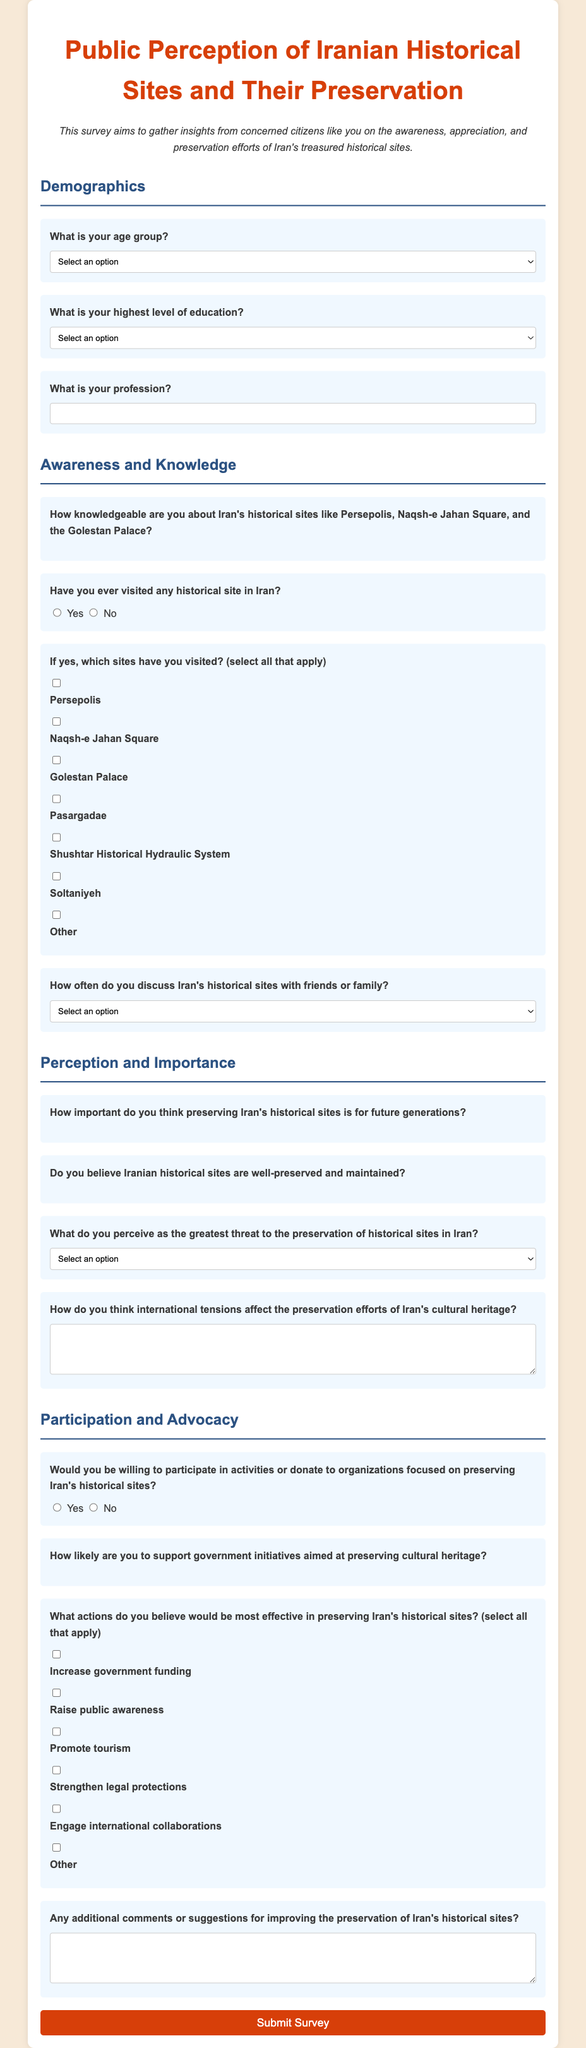What is the title of the survey? The title of the survey is displayed prominently at the top of the document.
Answer: Public Perception of Iranian Historical Sites and Their Preservation How many age group options are provided in the survey? The document presents a dropdown for selecting age groups with multiple options.
Answer: 5 What is the maximum education level option listed in the survey? The document includes a variety of education levels, with the highest listed in the options.
Answer: Doctorate What is the main purpose of the survey? The purpose is mentioned in the descriptive paragraph within the document.
Answer: Gather insights on the awareness, appreciation, and preservation efforts of Iran's historical sites What scale is used to rate knowledge about Iran's historical sites? The survey includes a rating system for assessing knowledge, which is displayed as stars.
Answer: 5-star scale Which historical site has its checkbox listed first in the visitation question? The options are listed sequentially, and the first checkbox corresponds to the first mentioned site.
Answer: Persepolis What aspect do respondents rate regarding the preservation of historical sites? The survey includes a section where respondents express their views on the preservation of sites.
Answer: Importance for future generations What is asked regarding the perception of threats to historical sites? The survey contains a question asking respondents to identify perceived threats to preservation.
Answer: Select greatest threat What is the maximum number of actions suggested for preserving historical sites? The document provides multiple checkboxes for actions that can be selected.
Answer: Multiple options 